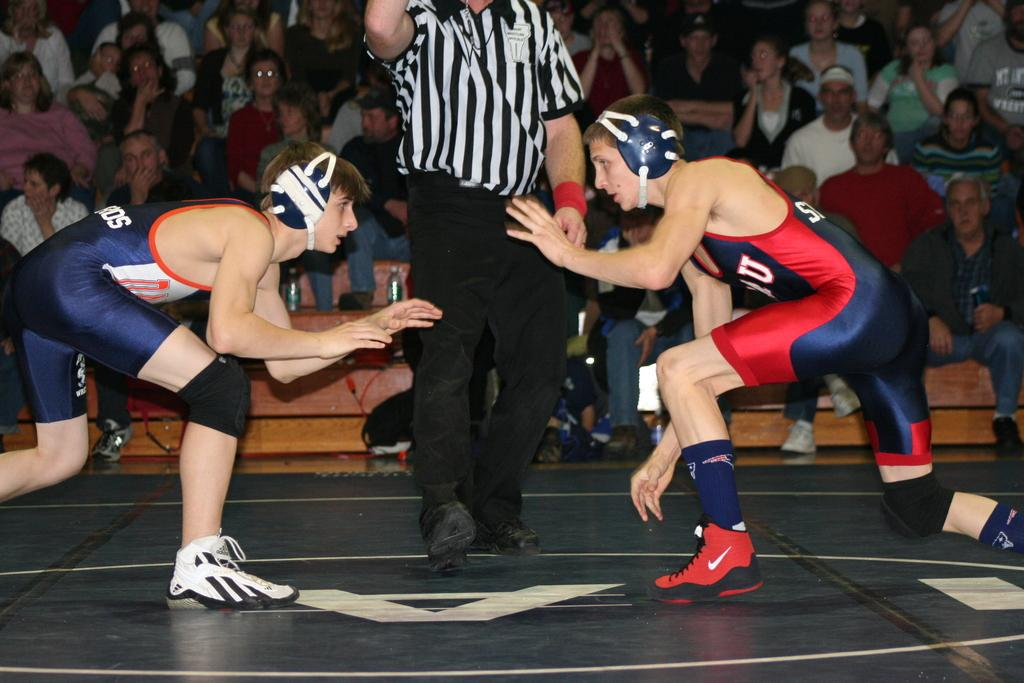<image>
Give a short and clear explanation of the subsequent image. two wrestlers fighting with the letter A under them 